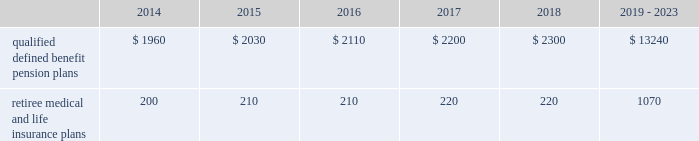Valuation techniques 2013 cash equivalents are mostly comprised of short-term money-market instruments and are valued at cost , which approximates fair value .
U.s .
Equity securities and international equity securities categorized as level 1 are traded on active national and international exchanges and are valued at their closing prices on the last trading day of the year .
For u.s .
Equity securities and international equity securities not traded on an active exchange , or if the closing price is not available , the trustee obtains indicative quotes from a pricing vendor , broker , or investment manager .
These securities are categorized as level 2 if the custodian obtains corroborated quotes from a pricing vendor or categorized as level 3 if the custodian obtains uncorroborated quotes from a broker or investment manager .
Commingled equity funds are investment vehicles valued using the net asset value ( nav ) provided by the fund managers .
The nav is the total value of the fund divided by the number of shares outstanding .
Commingled equity funds are categorized as level 1 if traded at their nav on a nationally recognized securities exchange or categorized as level 2 if the nav is corroborated by observable market data ( e.g. , purchases or sales activity ) and we are able to redeem our investment in the near-term .
Fixed income investments categorized as level 2 are valued by the trustee using pricing models that use verifiable observable market data ( e.g. , interest rates and yield curves observable at commonly quoted intervals and credit spreads ) , bids provided by brokers or dealers , or quoted prices of securities with similar characteristics .
Fixed income investments are categorized at level 3 when valuations using observable inputs are unavailable .
The trustee obtains pricing based on indicative quotes or bid evaluations from vendors , brokers , or the investment manager .
Private equity funds , real estate funds , and hedge funds are valued using the nav based on valuation models of underlying securities which generally include significant unobservable inputs that cannot be corroborated using verifiable observable market data .
Valuations for private equity funds and real estate funds are determined by the general partners .
Depending on the nature of the assets , the general partners may use various valuation methodologies , including the income and market approaches in their models .
The market approach consists of analyzing market transactions for comparable assets while the income approach uses earnings or the net present value of estimated future cash flows adjusted for liquidity and other risk factors .
Hedge funds are valued by independent administrators using various pricing sources and models based on the nature of the securities .
Private equity funds , real estate funds , and hedge funds are generally categorized as level 3 as we cannot fully redeem our investment in the near-term .
Commodities are traded on an active commodity exchange and are valued at their closing prices on the last trading day of the year .
Contributions and expected benefit payments we generally determine funding requirements for our defined benefit pension plans in a manner consistent with cas and internal revenue code rules .
In 2013 , we made contributions of $ 2.25 billion related to our qualified defined benefit pension plans .
We currently plan to make contributions of approximately $ 1.0 billion related to the qualified defined benefit pension plans in 2014 .
In 2013 , we made contributions of $ 98 million to our retiree medical and life insurance plans .
We do not expect to make contributions related to the retiree medical and life insurance plans in 2014 as a result of our 2013 contributions .
The table presents estimated future benefit payments , which reflect expected future employee service , as of december 31 , 2013 ( in millions ) : .
Defined contribution plans we maintain a number of defined contribution plans , most with 401 ( k ) features , that cover substantially all of our employees .
Under the provisions of our 401 ( k ) plans , we match most employees 2019 eligible contributions at rates specified in the plan documents .
Our contributions were $ 383 million in 2013 , $ 380 million in 2012 , and $ 378 million in 2011 , the majority of which were funded in our common stock .
Our defined contribution plans held approximately 44.7 million and 48.6 million shares of our common stock as of december 31 , 2013 and 2012. .
As of 2013 what was the ratio of the estimated future benefit payments after 2019 to the amounts in 2014? 
Computations: (13240 / 1960)
Answer: 6.7551. 